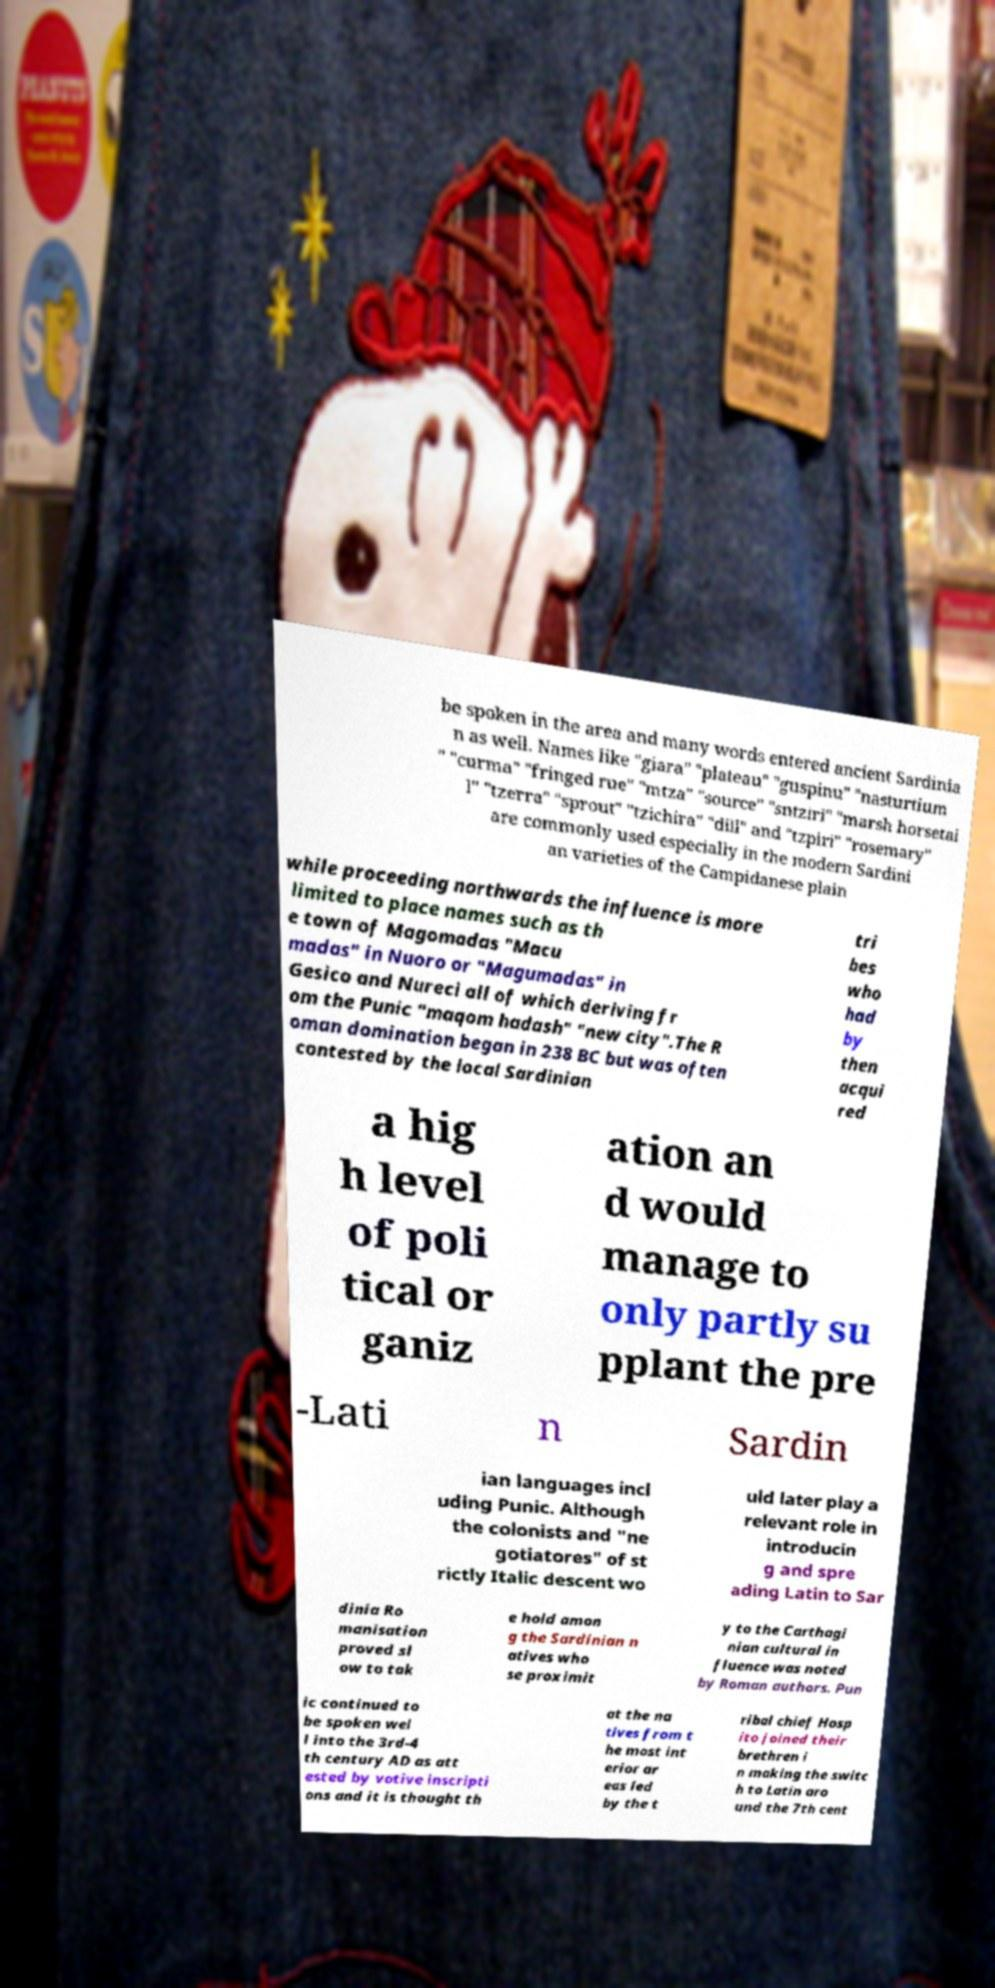For documentation purposes, I need the text within this image transcribed. Could you provide that? be spoken in the area and many words entered ancient Sardinia n as well. Names like "giara" "plateau" "guspinu" "nasturtium " "curma" "fringed rue" "mtza" "source" "sntziri" "marsh horsetai l" "tzerra" "sprout" "tzichira" "dill" and "tzpiri" "rosemary" are commonly used especially in the modern Sardini an varieties of the Campidanese plain while proceeding northwards the influence is more limited to place names such as th e town of Magomadas "Macu madas" in Nuoro or "Magumadas" in Gesico and Nureci all of which deriving fr om the Punic "maqom hadash" "new city".The R oman domination began in 238 BC but was often contested by the local Sardinian tri bes who had by then acqui red a hig h level of poli tical or ganiz ation an d would manage to only partly su pplant the pre -Lati n Sardin ian languages incl uding Punic. Although the colonists and "ne gotiatores" of st rictly Italic descent wo uld later play a relevant role in introducin g and spre ading Latin to Sar dinia Ro manisation proved sl ow to tak e hold amon g the Sardinian n atives who se proximit y to the Carthagi nian cultural in fluence was noted by Roman authors. Pun ic continued to be spoken wel l into the 3rd-4 th century AD as att ested by votive inscripti ons and it is thought th at the na tives from t he most int erior ar eas led by the t ribal chief Hosp ito joined their brethren i n making the switc h to Latin aro und the 7th cent 